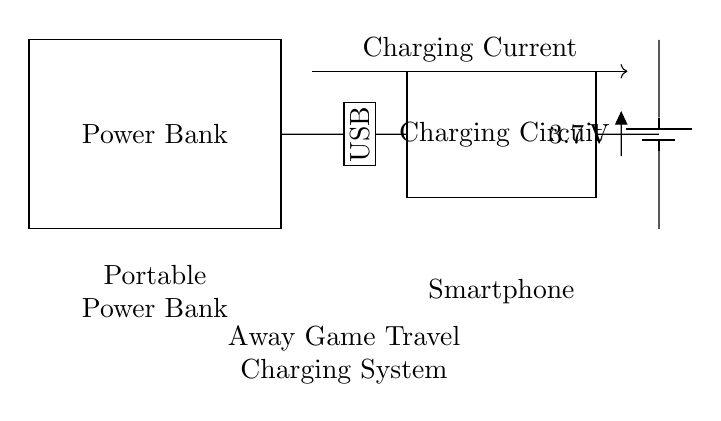What device is being charged in this circuit? The circuit diagram indicates a smartphone is being charged, as labeled near the charging current direction and the components involved.
Answer: smartphone What type of voltage does the battery output? The battery in the circuit outputs a voltage of three point seven volts, as noted on the diagram next to the battery component.
Answer: three point seven volts What is the purpose of the charging circuit? The charging circuit is designed to manage the charging process for the battery, ensuring proper voltage and current are supplied to effectively charge the power bank and subsequently supply power to the smartphone.
Answer: manage charging What is the role of the USB port in this system? The USB port serves as the interface through which power is delivered from the power bank to the charging circuit, which then charges the battery.
Answer: power delivery What direction is the charging current flowing in this circuit? The charging current flows from the USB port into the charging circuit and subsequently to the battery, as indicated by the arrow marking the current direction in the circuit diagram.
Answer: from USB to charging circuit What component stores energy in this circuit? The battery is the component that stores energy in this circuit, allowing it to supply power to the smartphone during travel.
Answer: battery 